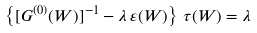<formula> <loc_0><loc_0><loc_500><loc_500>\left \{ [ G ^ { ( 0 ) } ( W ) ] ^ { - 1 } - \lambda \, \varepsilon ( W ) \right \} \, \tau ( W ) = \lambda \,</formula> 